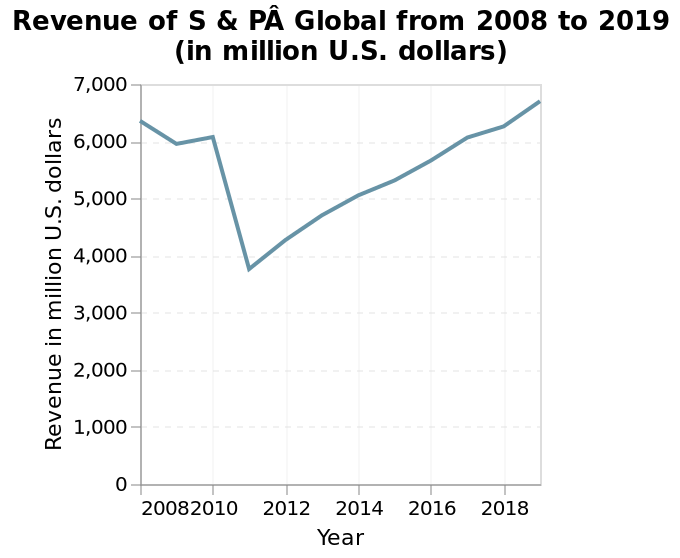<image>
What happened to the revenue of S and PA in 2011? The revenue of S and PA took a severe dip in 2011. Which organization's revenue is being depicted in the chart? The chart represents the revenue of S & P Global. please summary the statistics and relations of the chart In 2008, revenue for S & PA Global was roughly 6,500 in millions of US dollars. This figure fell to approximately 3,800 in 2011, its lowest point on the graph. Earnings then rebounded steadily from 2011 to 2019, with an overall growth from 3,800 to just over 6,500 millions of US dollars by 2019, representing a slight increase over the starting revenue in 2008. 